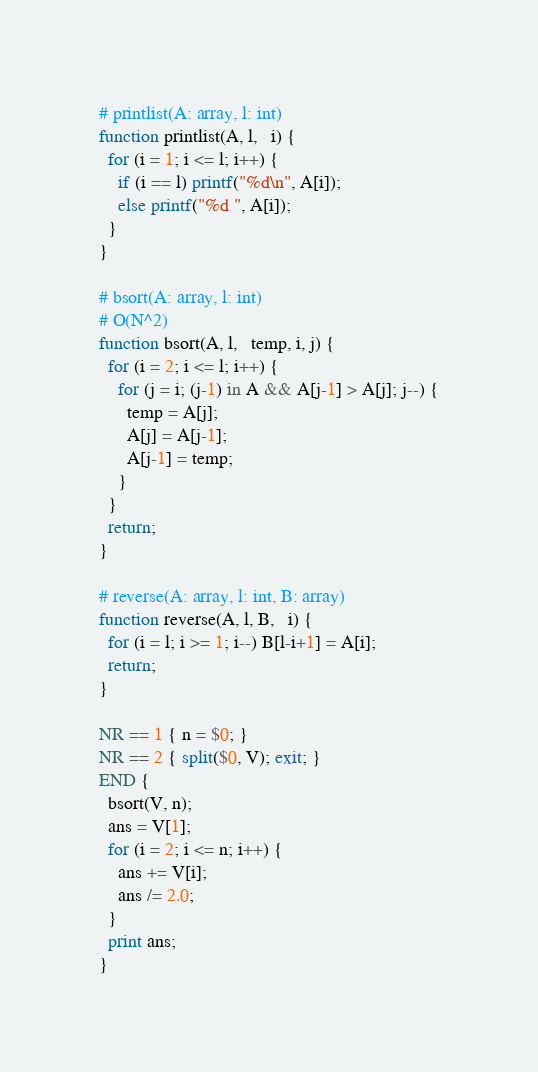<code> <loc_0><loc_0><loc_500><loc_500><_Awk_># printlist(A: array, l: int)
function printlist(A, l,   i) {
  for (i = 1; i <= l; i++) {
    if (i == l) printf("%d\n", A[i]);
    else printf("%d ", A[i]);
  }
}

# bsort(A: array, l: int)
# O(N^2)
function bsort(A, l,   temp, i, j) {
  for (i = 2; i <= l; i++) {
    for (j = i; (j-1) in A && A[j-1] > A[j]; j--) {
      temp = A[j];
      A[j] = A[j-1];
      A[j-1] = temp;
    }
  }
  return;
}

# reverse(A: array, l: int, B: array)
function reverse(A, l, B,   i) {
  for (i = l; i >= 1; i--) B[l-i+1] = A[i];
  return;
}

NR == 1 { n = $0; }
NR == 2 { split($0, V); exit; }
END {
  bsort(V, n);
  ans = V[1];
  for (i = 2; i <= n; i++) {
    ans += V[i];
    ans /= 2.0;
  }
  print ans;
}
</code> 